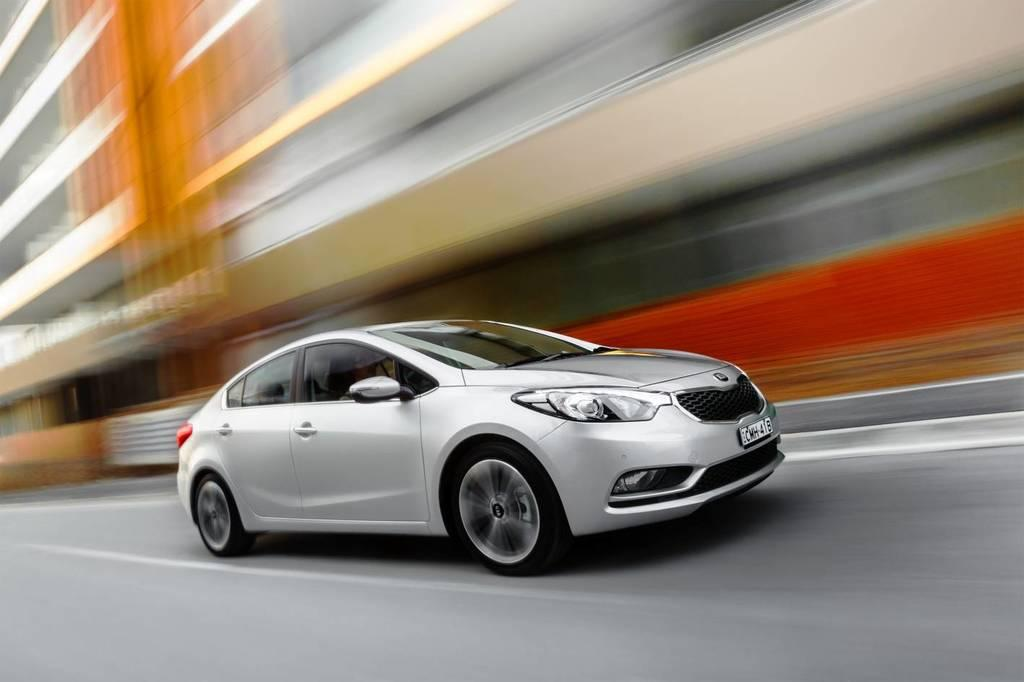What is the main subject of the image? The main subject of the image is a car on the road. Can you describe the setting of the image? There is a building visible in the image, which suggests that the car is on a road near a building. How does the visitor breathe in the image? There is no visitor present in the image, so it is not possible to determine how they might breathe. 